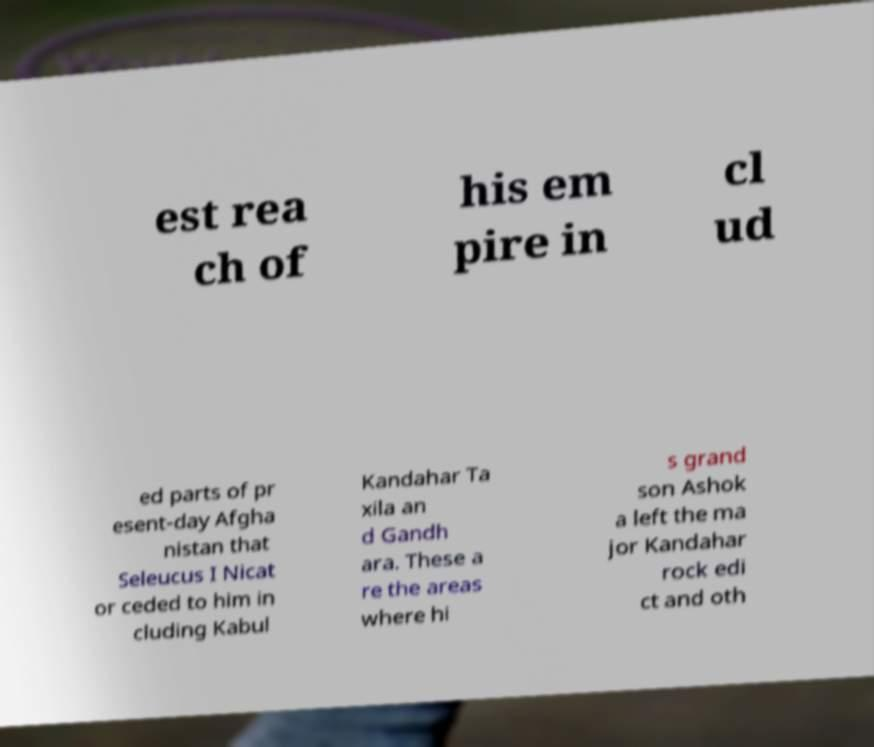Can you read and provide the text displayed in the image?This photo seems to have some interesting text. Can you extract and type it out for me? est rea ch of his em pire in cl ud ed parts of pr esent-day Afgha nistan that Seleucus I Nicat or ceded to him in cluding Kabul Kandahar Ta xila an d Gandh ara. These a re the areas where hi s grand son Ashok a left the ma jor Kandahar rock edi ct and oth 